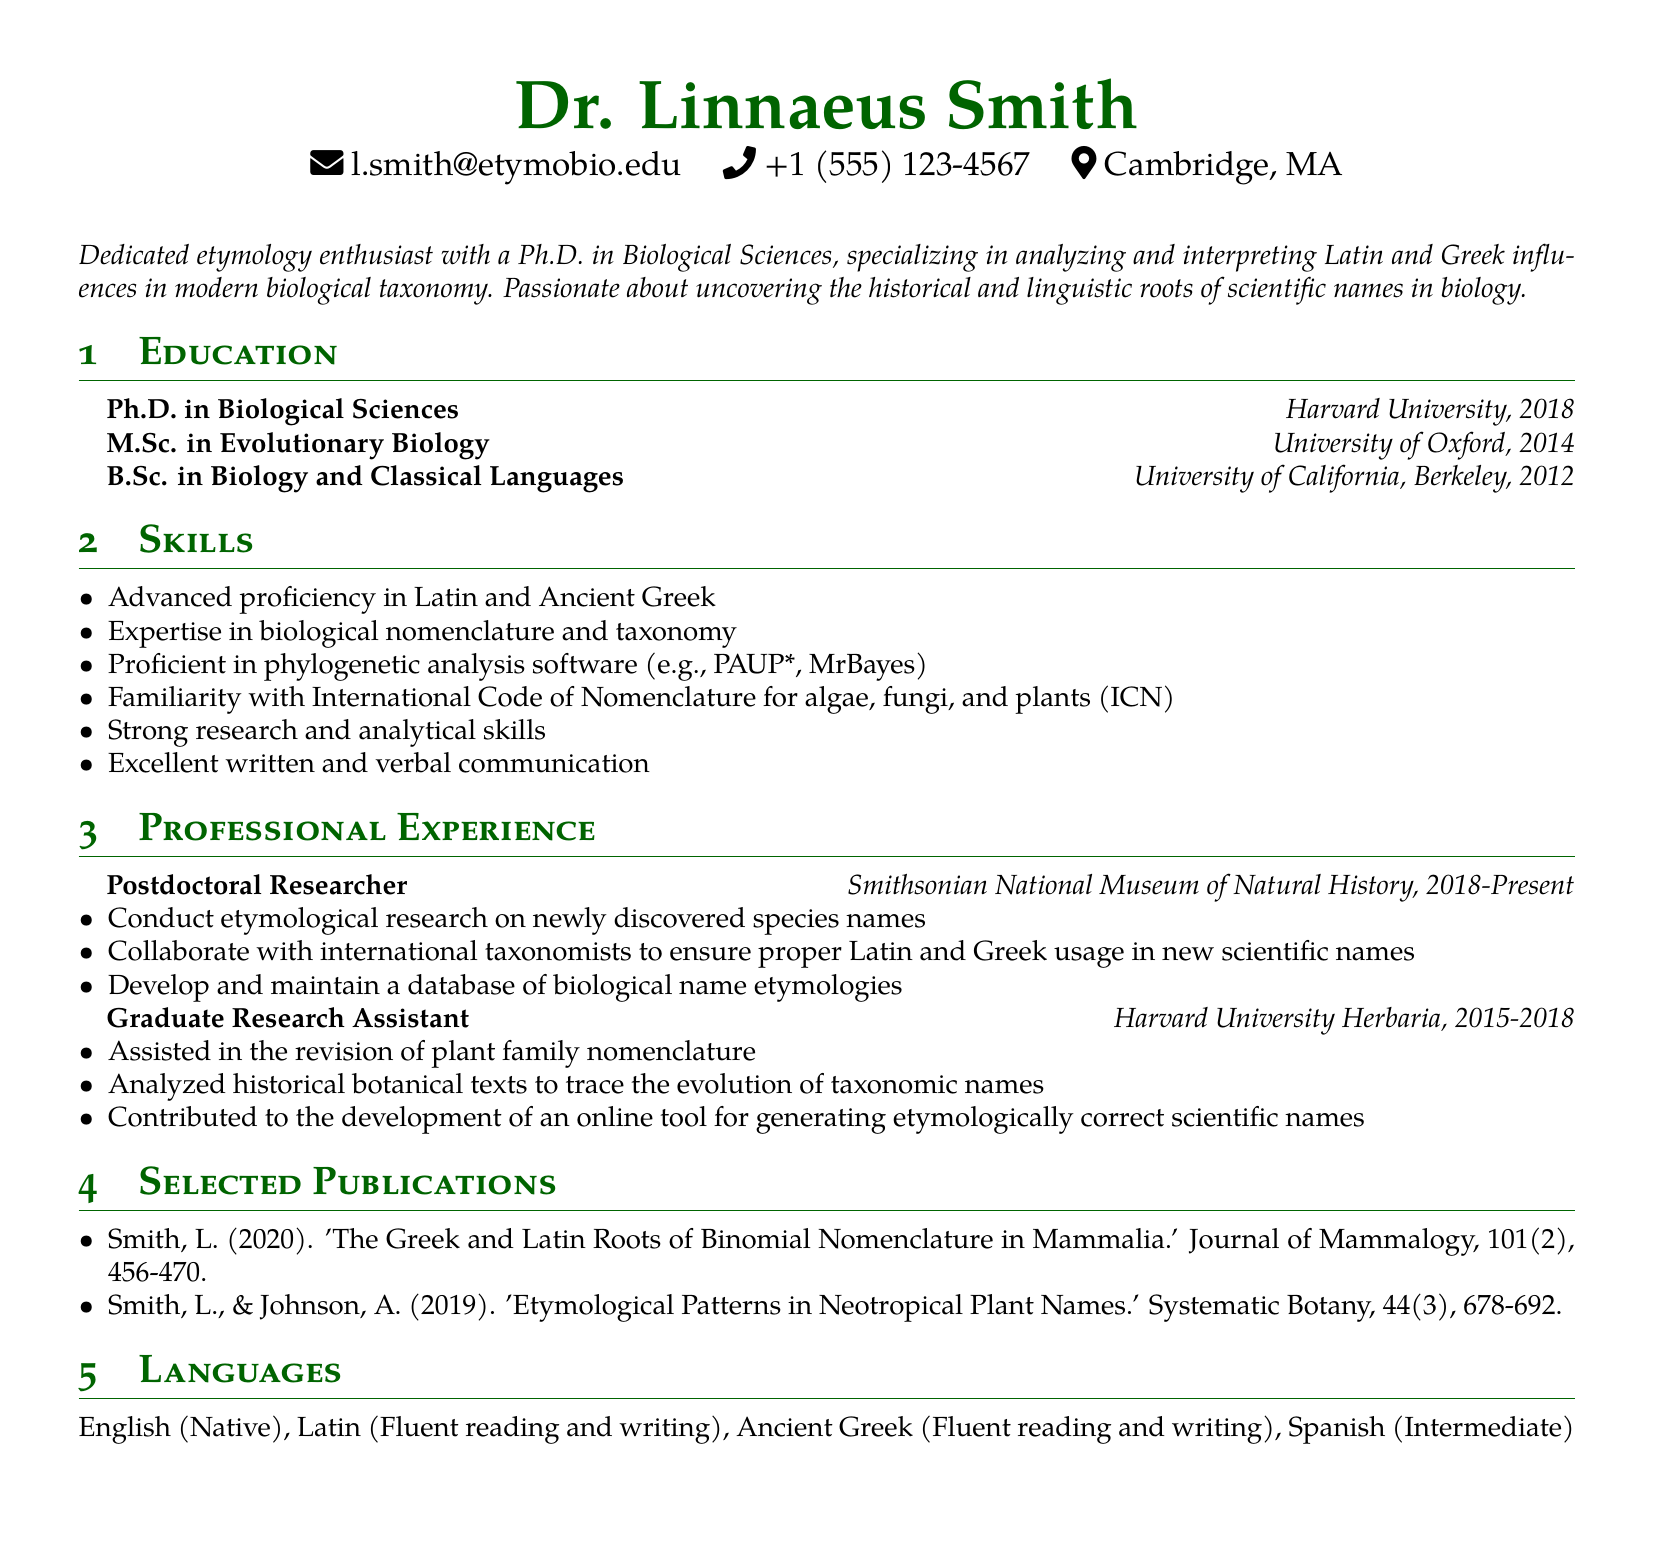what is the name of the individual? The document specifies the name at the top of the CV.
Answer: Dr. Linnaeus Smith what is the highest degree obtained? The highest degree listed in the education section is found by the chronological order of education.
Answer: Ph.D. in Biological Sciences where did the individual receive their M.Sc. degree? The education section identifies where Dr. Smith received their M.Sc. degree.
Answer: University of Oxford what is one of the research responsibilities at the Smithsonian National Museum of Natural History? The responsibilities in the professional experience section detail roles in the position held.
Answer: Conduct etymological research on newly discovered species names how many years did the individual work at Harvard University Herbaria? The duration of employment is provided in the professional experience section.
Answer: 3 years which languages can Dr. Smith read and write fluently? The languages section outlines Dr. Smith's language skills, specifically which ones are fluent.
Answer: Latin, Ancient Greek what type of software is Dr. Smith proficient in? The skills section lists the specific software relevant to Dr. Smith's expertise.
Answer: Phylogenetic analysis software what is the publication year of the first listed publication? The publication year can be found directly in the publication section.
Answer: 2020 what role did Dr. Smith have before becoming a Postdoctoral Researcher? The document indicates Dr. Smith's previous position in the professional experience section.
Answer: Graduate Research Assistant 